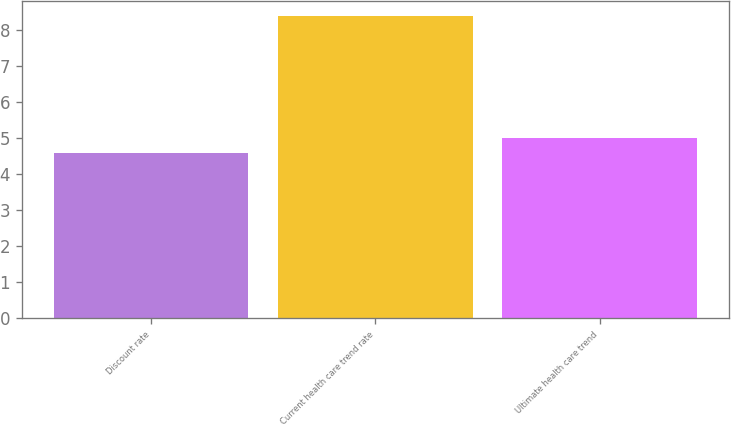<chart> <loc_0><loc_0><loc_500><loc_500><bar_chart><fcel>Discount rate<fcel>Current health care trend rate<fcel>Ultimate health care trend<nl><fcel>4.6<fcel>8.4<fcel>5<nl></chart> 